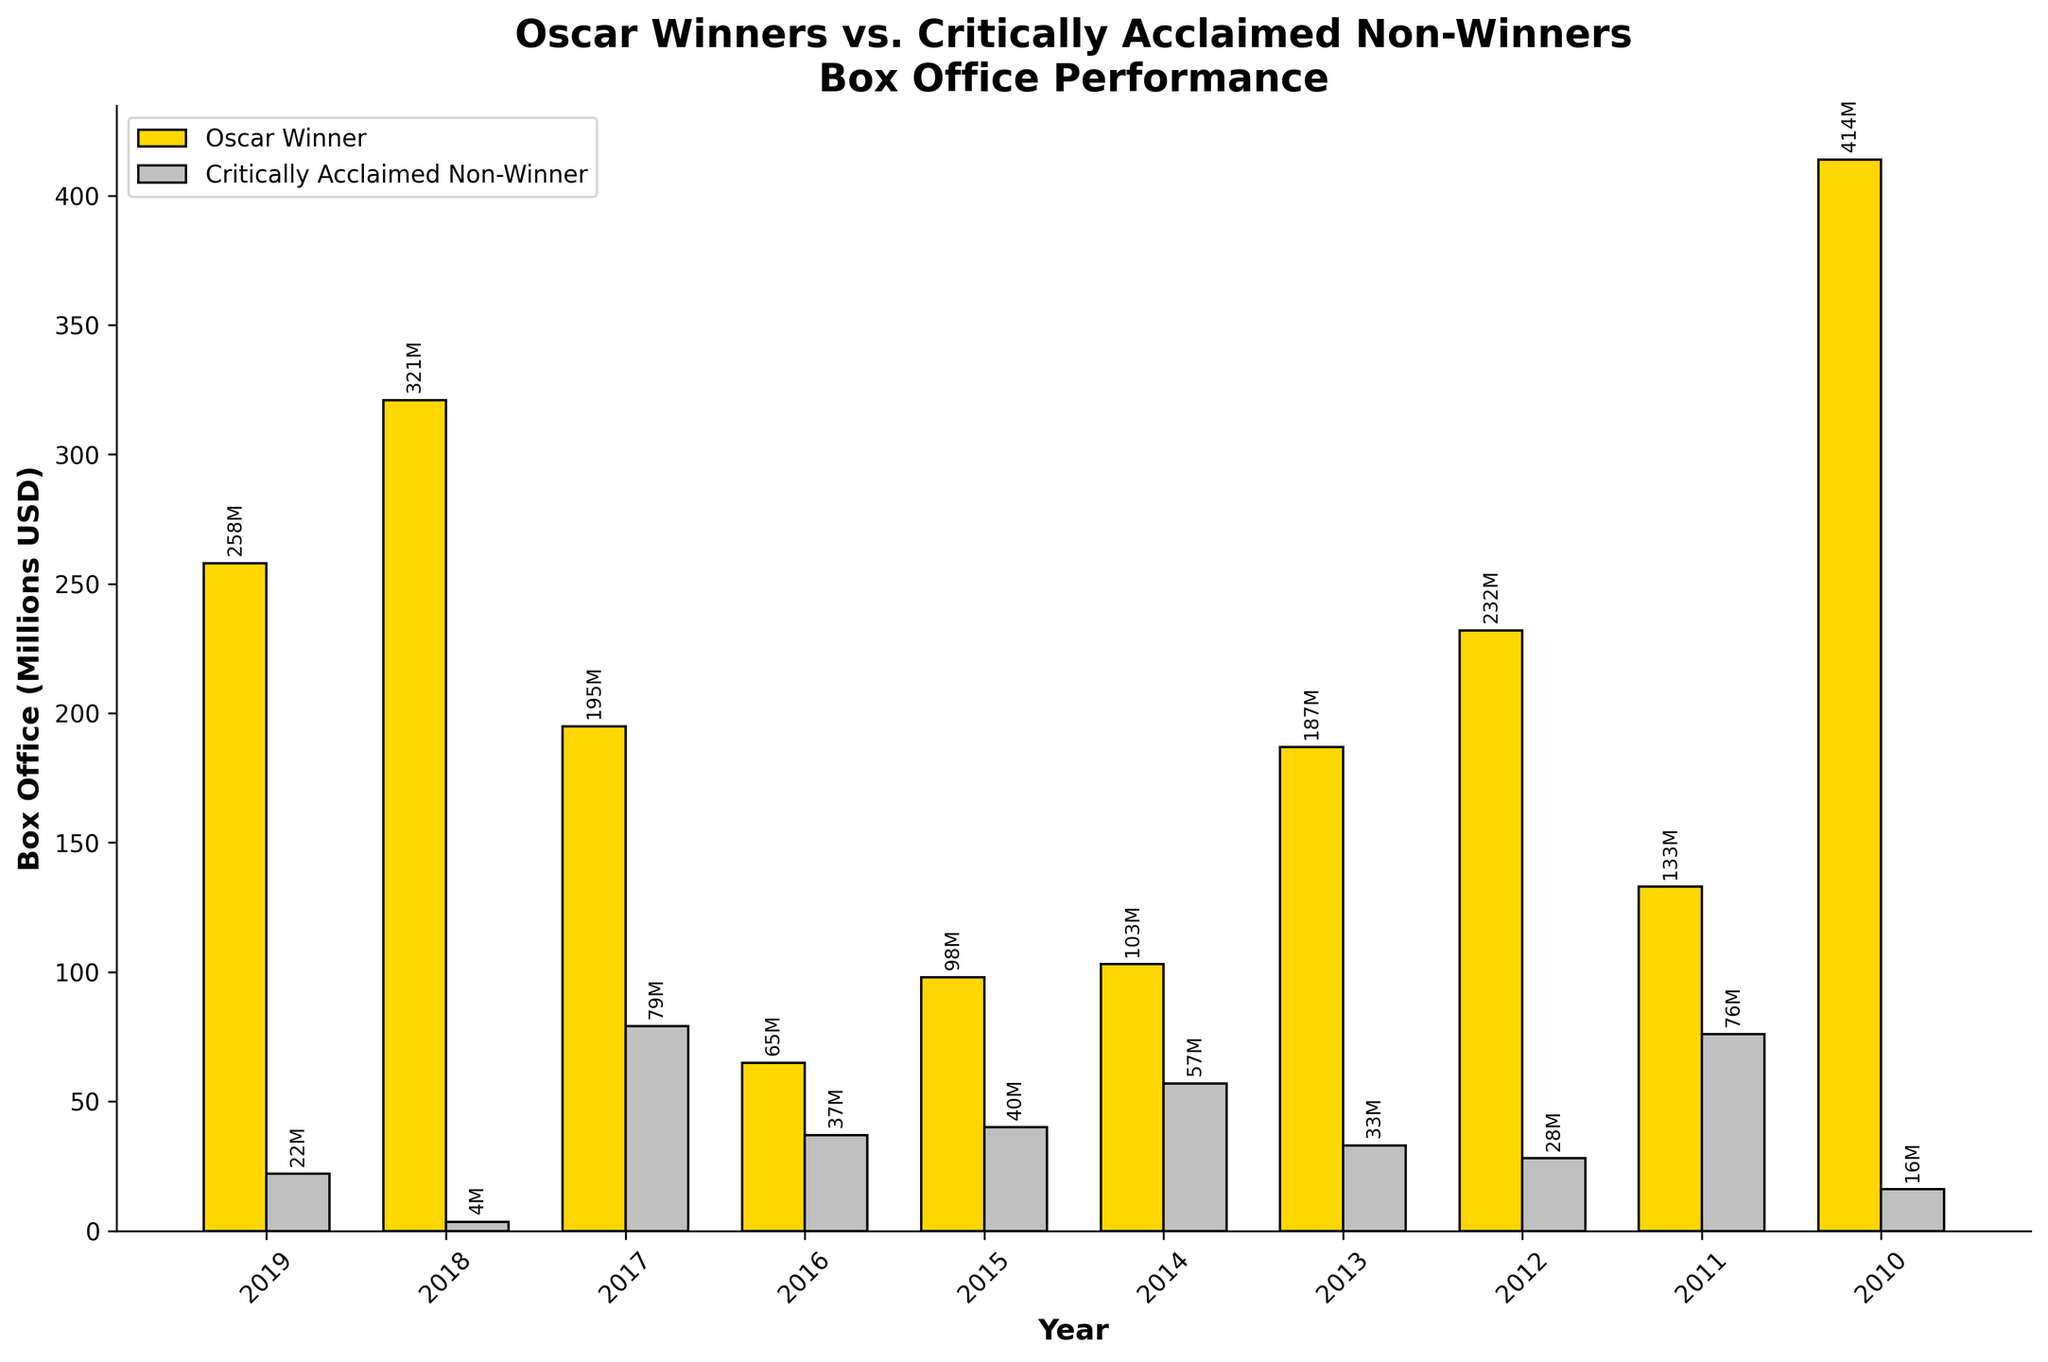Which year had the highest box office performance for an Oscar-winning film? Let's analyze the heights of the gold-colored bars (Oscar Winners) in the bar chart. The tallest bar for Oscar winners is in 2010 with "The King's Speech" having a box office of 414 million USD.
Answer: 2010 Comparing 2016, which film had a higher box office performance: the Oscar winner or the critically acclaimed non-winner? In 2016, the height of the gold bar representing the Oscar winner "Moonlight" is 65 million USD, while the height of the silver bar representing the critically acclaimed non-winner "Hell or High Water" is 37 million USD. The Oscar winner had a higher box office performance.
Answer: Oscar winner What is the average box office performance of Oscar-winning films over these 10 years? First, sum up the box office of all Oscar-winning films: 258 + 321 + 195 + 65 + 98 + 103 + 187 + 232 + 133 + 414 = 2006 million USD. Divide this sum by the number of years (10): 2006 / 10 = 200.6 million USD.
Answer: 200.6 million USD Which year had the smallest difference in box office performance between the Oscar winner and the critically acclaimed non-winner? We need to calculate the absolute differences for each year and find the smallest one. For each year, the differences are as follows: 2019 (258 - 22) = 236, 2018 (321 - 3.5) = 317.5, 2017 (195 - 79) = 116, 2016 (65 - 37) = 28, 2015 (98 - 40) = 58, 2014 (103 - 57) = 46, 2013 (187 - 33) = 154, 2012 (232 - 28) = 204, 2011 (133 - 76) = 57, 2010 (414 - 16) = 398. The smallest difference is in 2016 with a difference of 28 million USD.
Answer: 2016 How many Oscar-winning films had a box office performance greater than 200 million USD? By looking at the heights of the gold-colored bars and checking their annotated values, the years with a box office performance greater than 200 million USD are 2019 (258 million), 2018 (321 million), 2012 (232 million), and 2010 (414 million). Therefore, there are 4 such films.
Answer: 4 What is the total box office performance for critically acclaimed non-winners over these 10 years? Sum up the box office of all critically acclaimed non-winners: 22 + 3.5 + 79 + 37 + 40 + 57 + 33 + 28 + 76 + 16 = 391.5 million USD.
Answer: 391.5 million USD Which year had the highest box office performance for critically acclaimed non-winners? By analyzing the heights of the silver-colored bars, the tallest bar for critically acclaimed non-winners is in 2017 with "Lady Bird" having a box office of 79 million USD.
Answer: 2017 Which year shows the widest gap between the box office performances of Oscar winners and critically acclaimed non-winners? We need to calculate the absolute differences for each year and find the largest one. For each year, the differences are as follows: 2019 (258 - 22) = 236, 2018 (321 - 3.5) = 317.5, 2017 (195 - 79) = 116, 2016 (65 - 37) = 28, 2015 (98 - 40) = 58, 2014 (103 - 57) = 46, 2013 (187 - 33) = 154, 2012 (232 - 28) = 204, 2011 (133 - 76) = 57, 2010 (414 - 16) = 398. The largest difference is in 2010 with a gap of 398 million USD.
Answer: 2010 In how many years did critically acclaimed non-winners achieve more than 50 million USD in box office revenues? By looking at the heights of the silver-colored bars and checking their annotated values, the years where non-winners achieved more than 50 million USD are 2017 (79 million), 2015 (40 million but not above 50), 2014 (57 million), and 2011 (76 million). Therefore, there are 3 such years.
Answer: 3 